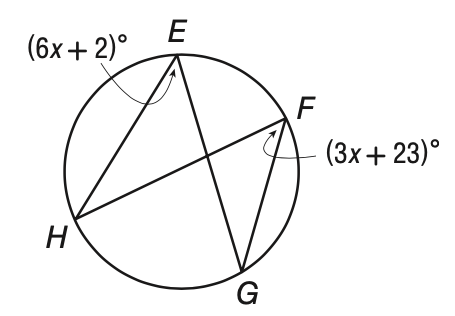Answer the mathemtical geometry problem and directly provide the correct option letter.
Question: Solve for x in the figure below.
Choices: A: 4 B: 5 C: 6 D: 7 D 